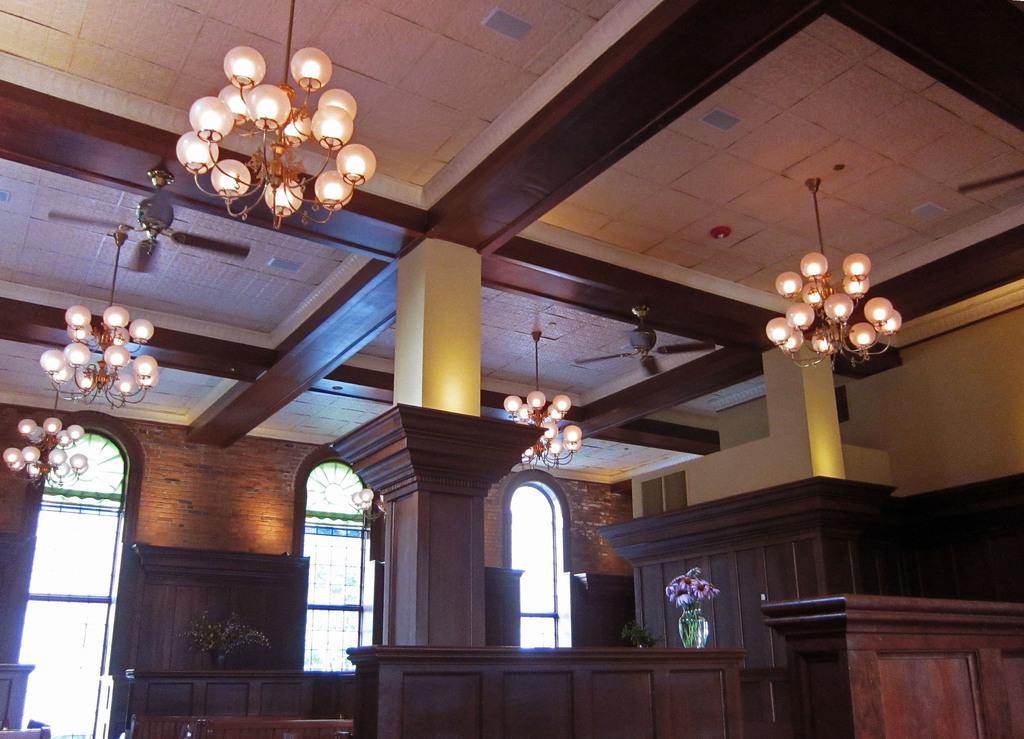Please provide a concise description of this image. In this image we can see lights, pillar, table, flower vase, wall and windows. 